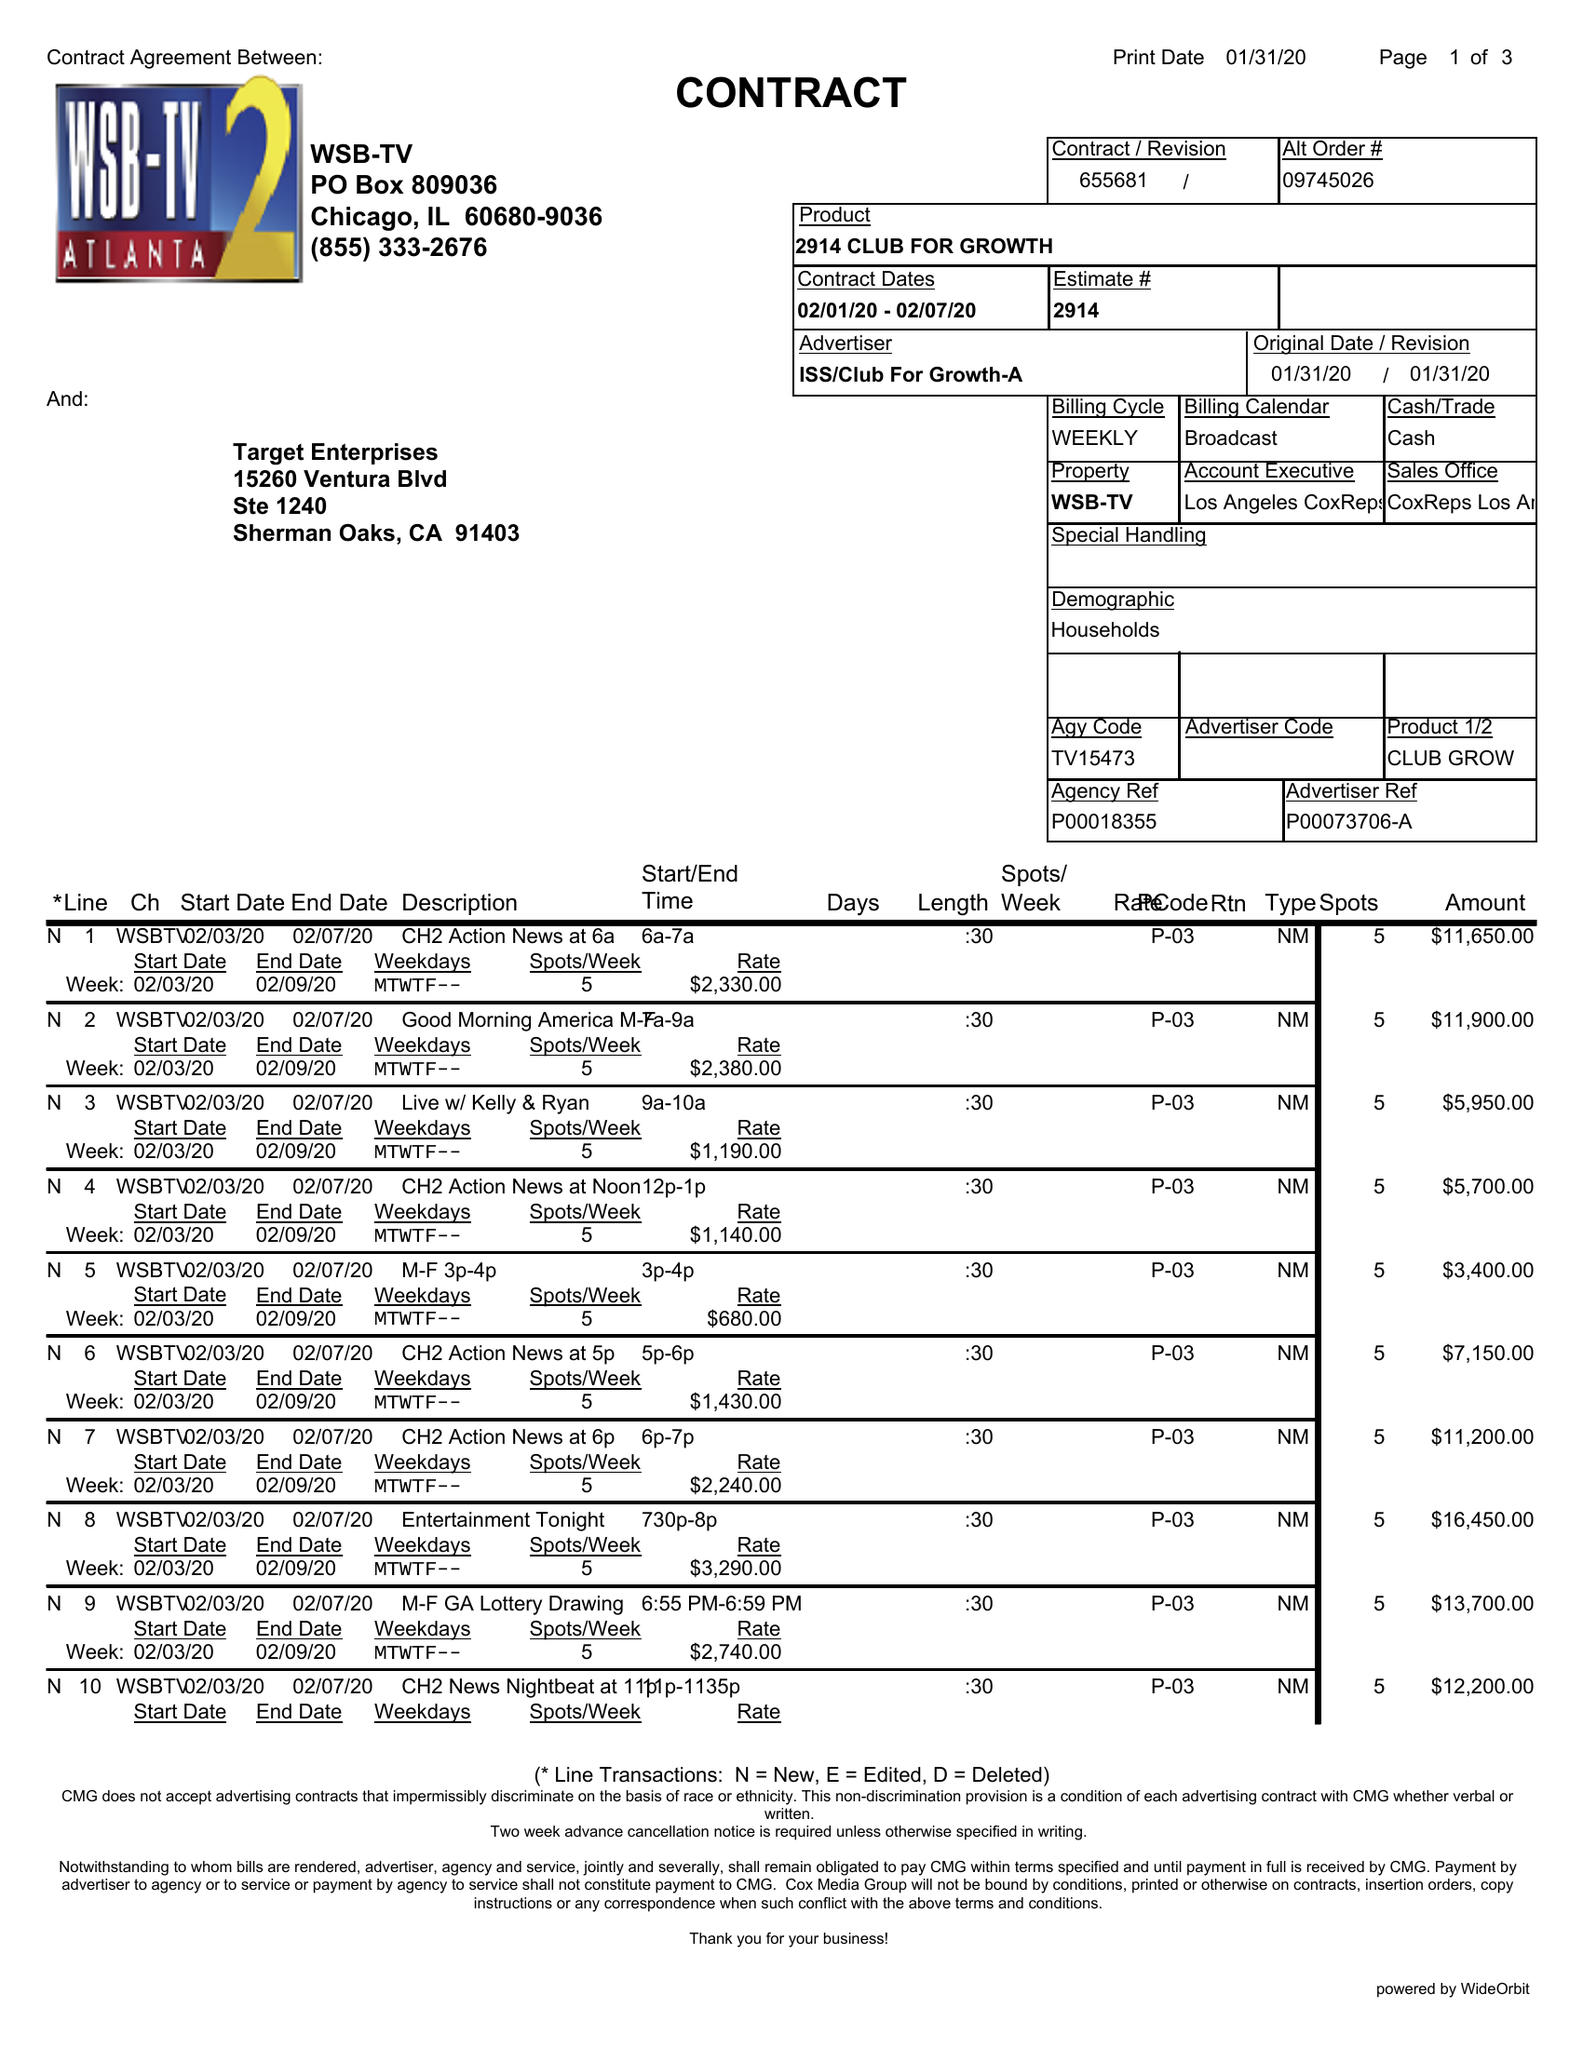What is the value for the advertiser?
Answer the question using a single word or phrase. ISS/CLUBFORGROWTH-A 